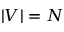Convert formula to latex. <formula><loc_0><loc_0><loc_500><loc_500>| V | = N</formula> 